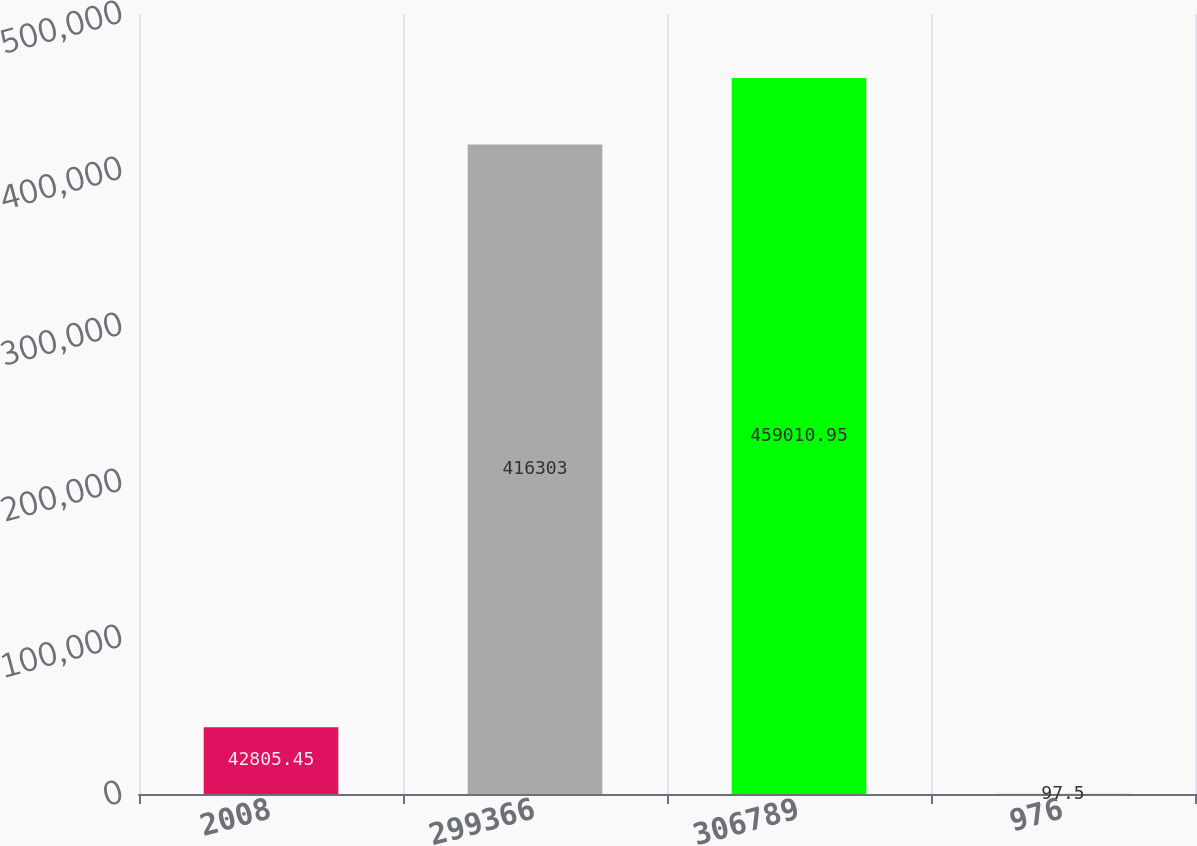Convert chart. <chart><loc_0><loc_0><loc_500><loc_500><bar_chart><fcel>2008<fcel>299366<fcel>306789<fcel>976<nl><fcel>42805.4<fcel>416303<fcel>459011<fcel>97.5<nl></chart> 